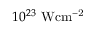<formula> <loc_0><loc_0><loc_500><loc_500>1 0 ^ { 2 3 } W c m ^ { - 2 }</formula> 